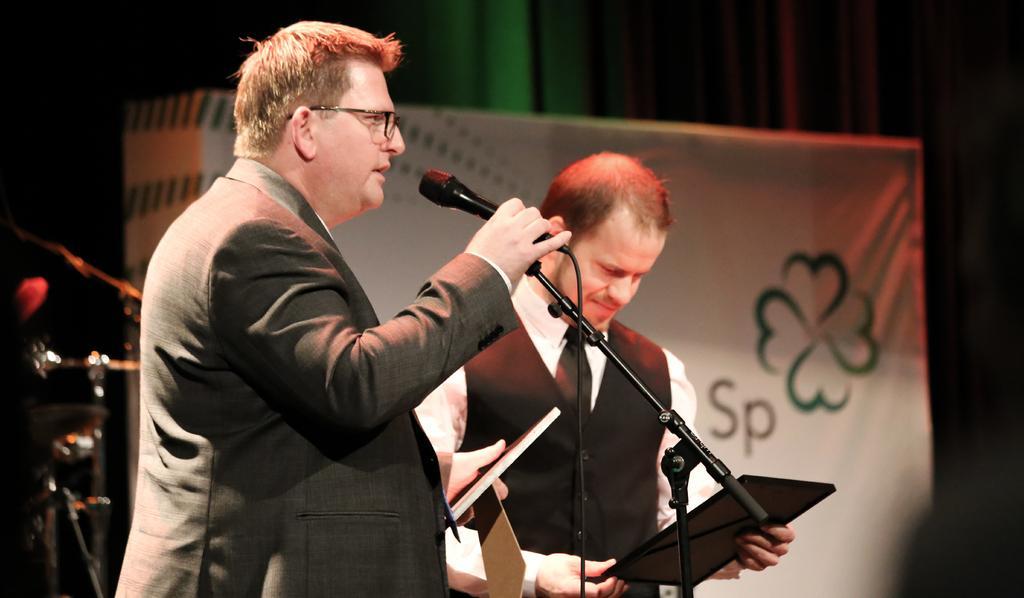In one or two sentences, can you explain what this image depicts? In this image there is a person standing and holding a mike in one hand and in the other hand, there is an object, beside this person there is another person standing and holding an object. In the background there is a banner. 